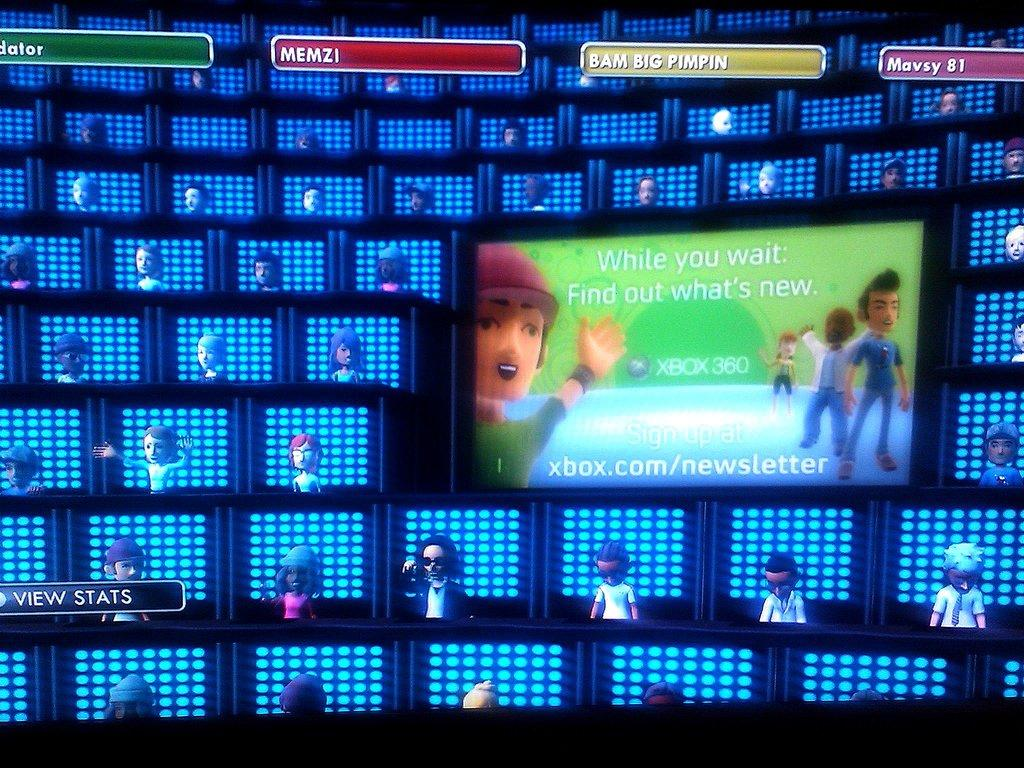Provide a one-sentence caption for the provided image. Digital avatars sit in rows of LED boxes with an advertisement for the Xbox Newsletter is displayed on a screen. 